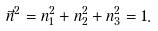Convert formula to latex. <formula><loc_0><loc_0><loc_500><loc_500>\vec { n } ^ { 2 } = n ^ { 2 } _ { 1 } + n ^ { 2 } _ { 2 } + n ^ { 2 } _ { 3 } = 1 .</formula> 